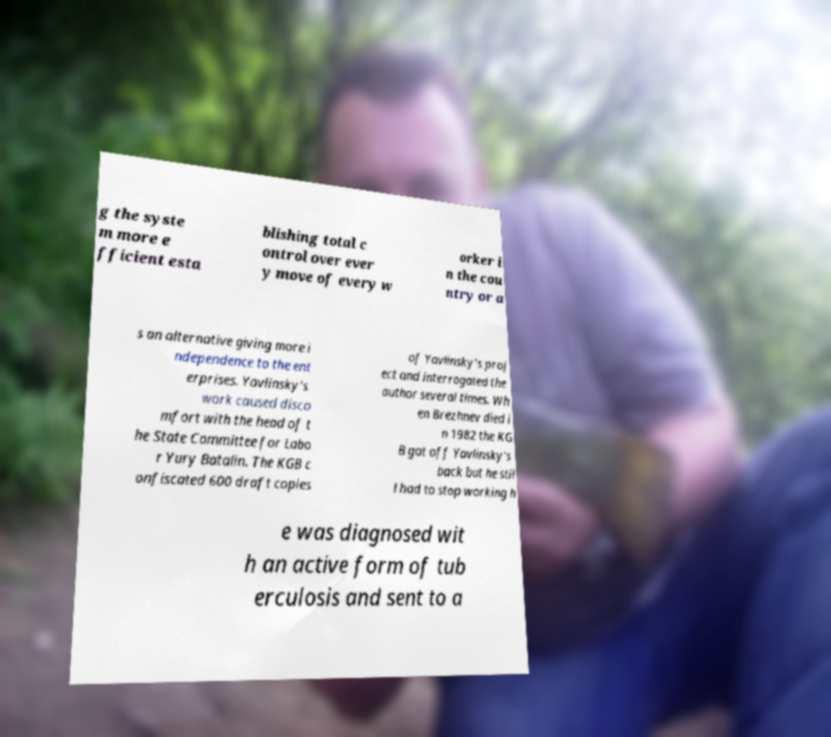Could you extract and type out the text from this image? g the syste m more e fficient esta blishing total c ontrol over ever y move of every w orker i n the cou ntry or a s an alternative giving more i ndependence to the ent erprises. Yavlinsky's work caused disco mfort with the head of t he State Committee for Labo r Yury Batalin. The KGB c onfiscated 600 draft copies of Yavlinsky's proj ect and interrogated the author several times. Wh en Brezhnev died i n 1982 the KG B got off Yavlinsky's back but he stil l had to stop working h e was diagnosed wit h an active form of tub erculosis and sent to a 